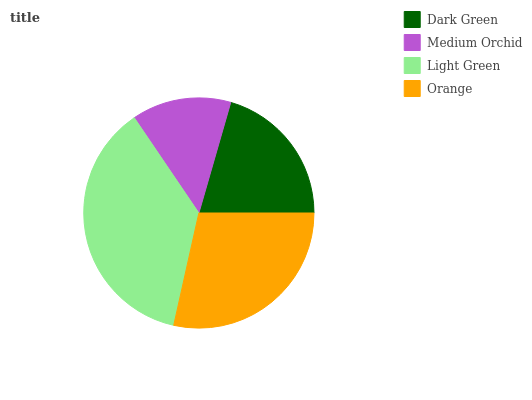Is Medium Orchid the minimum?
Answer yes or no. Yes. Is Light Green the maximum?
Answer yes or no. Yes. Is Light Green the minimum?
Answer yes or no. No. Is Medium Orchid the maximum?
Answer yes or no. No. Is Light Green greater than Medium Orchid?
Answer yes or no. Yes. Is Medium Orchid less than Light Green?
Answer yes or no. Yes. Is Medium Orchid greater than Light Green?
Answer yes or no. No. Is Light Green less than Medium Orchid?
Answer yes or no. No. Is Orange the high median?
Answer yes or no. Yes. Is Dark Green the low median?
Answer yes or no. Yes. Is Light Green the high median?
Answer yes or no. No. Is Orange the low median?
Answer yes or no. No. 